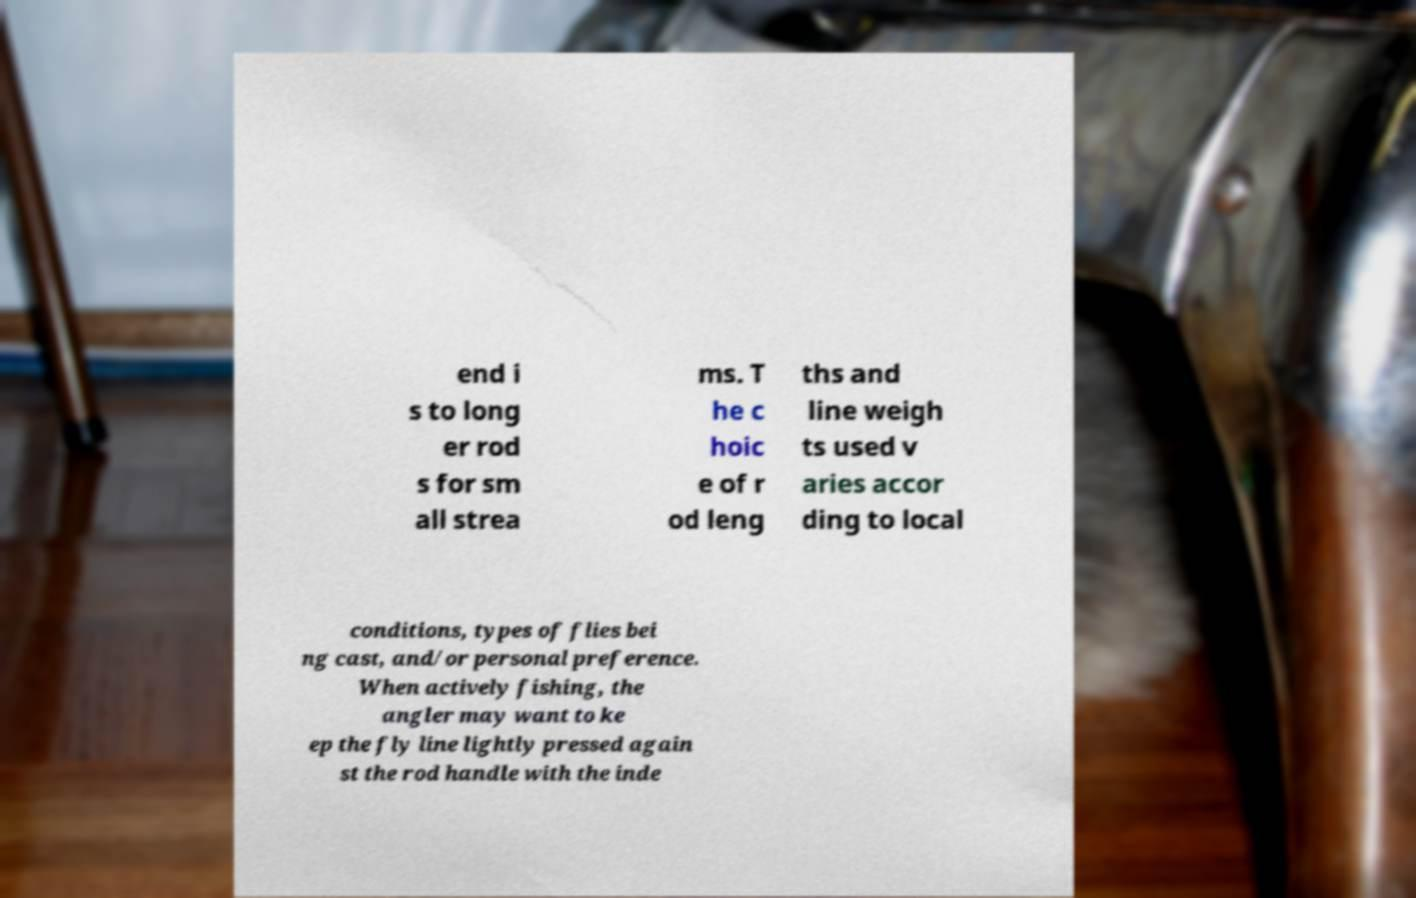Could you assist in decoding the text presented in this image and type it out clearly? end i s to long er rod s for sm all strea ms. T he c hoic e of r od leng ths and line weigh ts used v aries accor ding to local conditions, types of flies bei ng cast, and/or personal preference. When actively fishing, the angler may want to ke ep the fly line lightly pressed again st the rod handle with the inde 